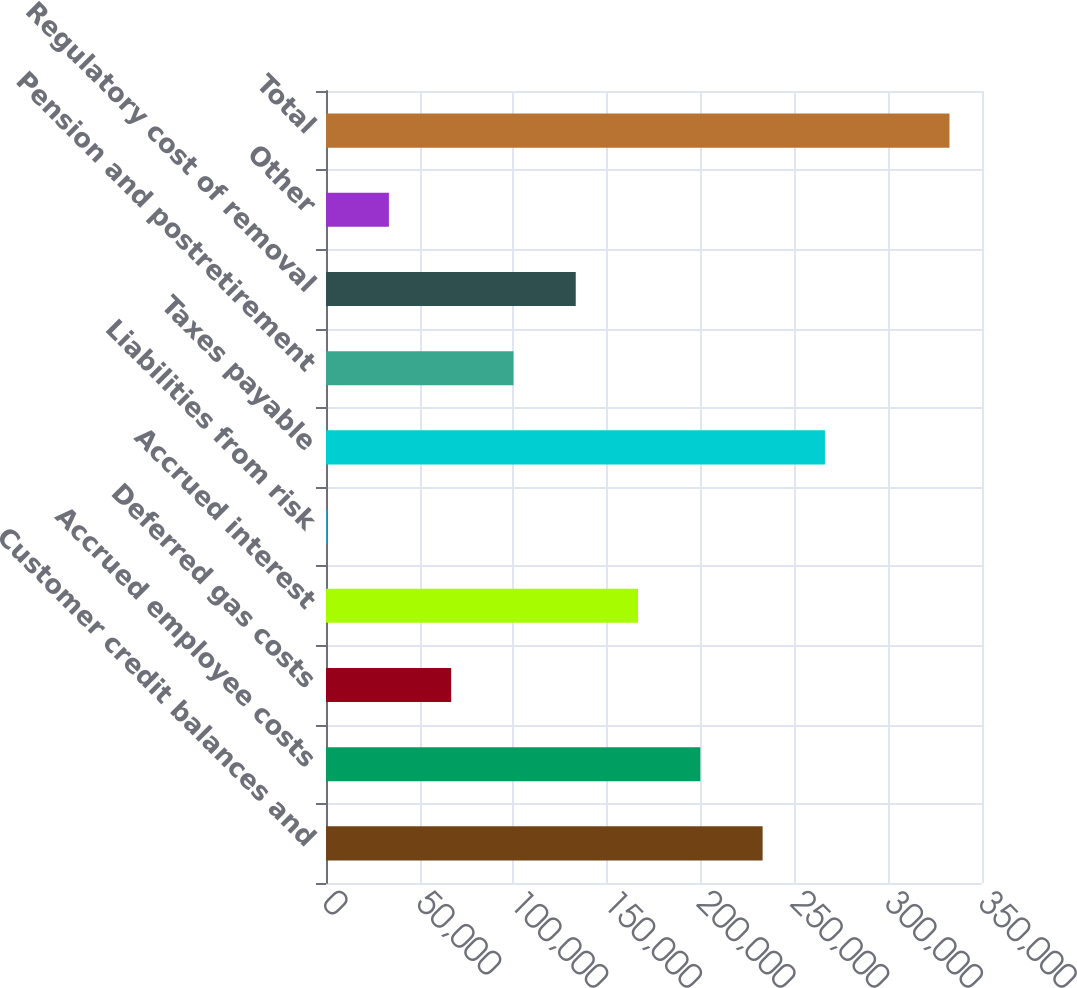Convert chart. <chart><loc_0><loc_0><loc_500><loc_500><bar_chart><fcel>Customer credit balances and<fcel>Accrued employee costs<fcel>Deferred gas costs<fcel>Accrued interest<fcel>Liabilities from risk<fcel>Taxes payable<fcel>Pension and postretirement<fcel>Regulatory cost of removal<fcel>Other<fcel>Total<nl><fcel>232950<fcel>199718<fcel>66787.2<fcel>166485<fcel>322<fcel>266183<fcel>100020<fcel>133252<fcel>33554.6<fcel>332648<nl></chart> 